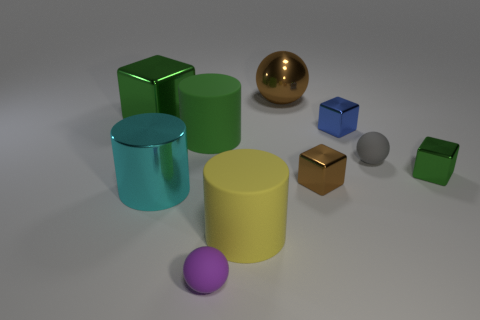What materials do the objects in the image appear to be made of? The objects in the image appear to have various materials: the green cube and cylinder, the teal cylinder, and the blue cube seem to be of a shiny, perhaps metallic finish. The yellow cylinder looks matte and could be plastic. The purple sphere appears matte as well, suggesting a rubber or plastic material. The golden sphere has a reflective surface, hinting at a metal, and the bronze cube might be of a similar metallic material. The gray sphere's less reflective surface possibly indicates a stone or concrete material. 